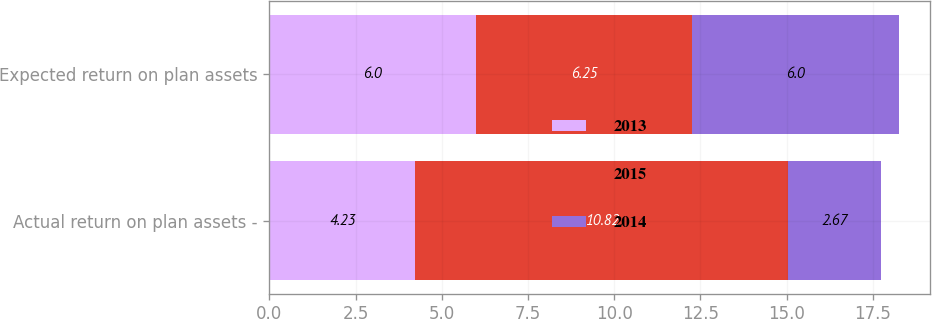<chart> <loc_0><loc_0><loc_500><loc_500><stacked_bar_chart><ecel><fcel>Actual return on plan assets -<fcel>Expected return on plan assets<nl><fcel>2013<fcel>4.23<fcel>6<nl><fcel>2015<fcel>10.82<fcel>6.25<nl><fcel>2014<fcel>2.67<fcel>6<nl></chart> 